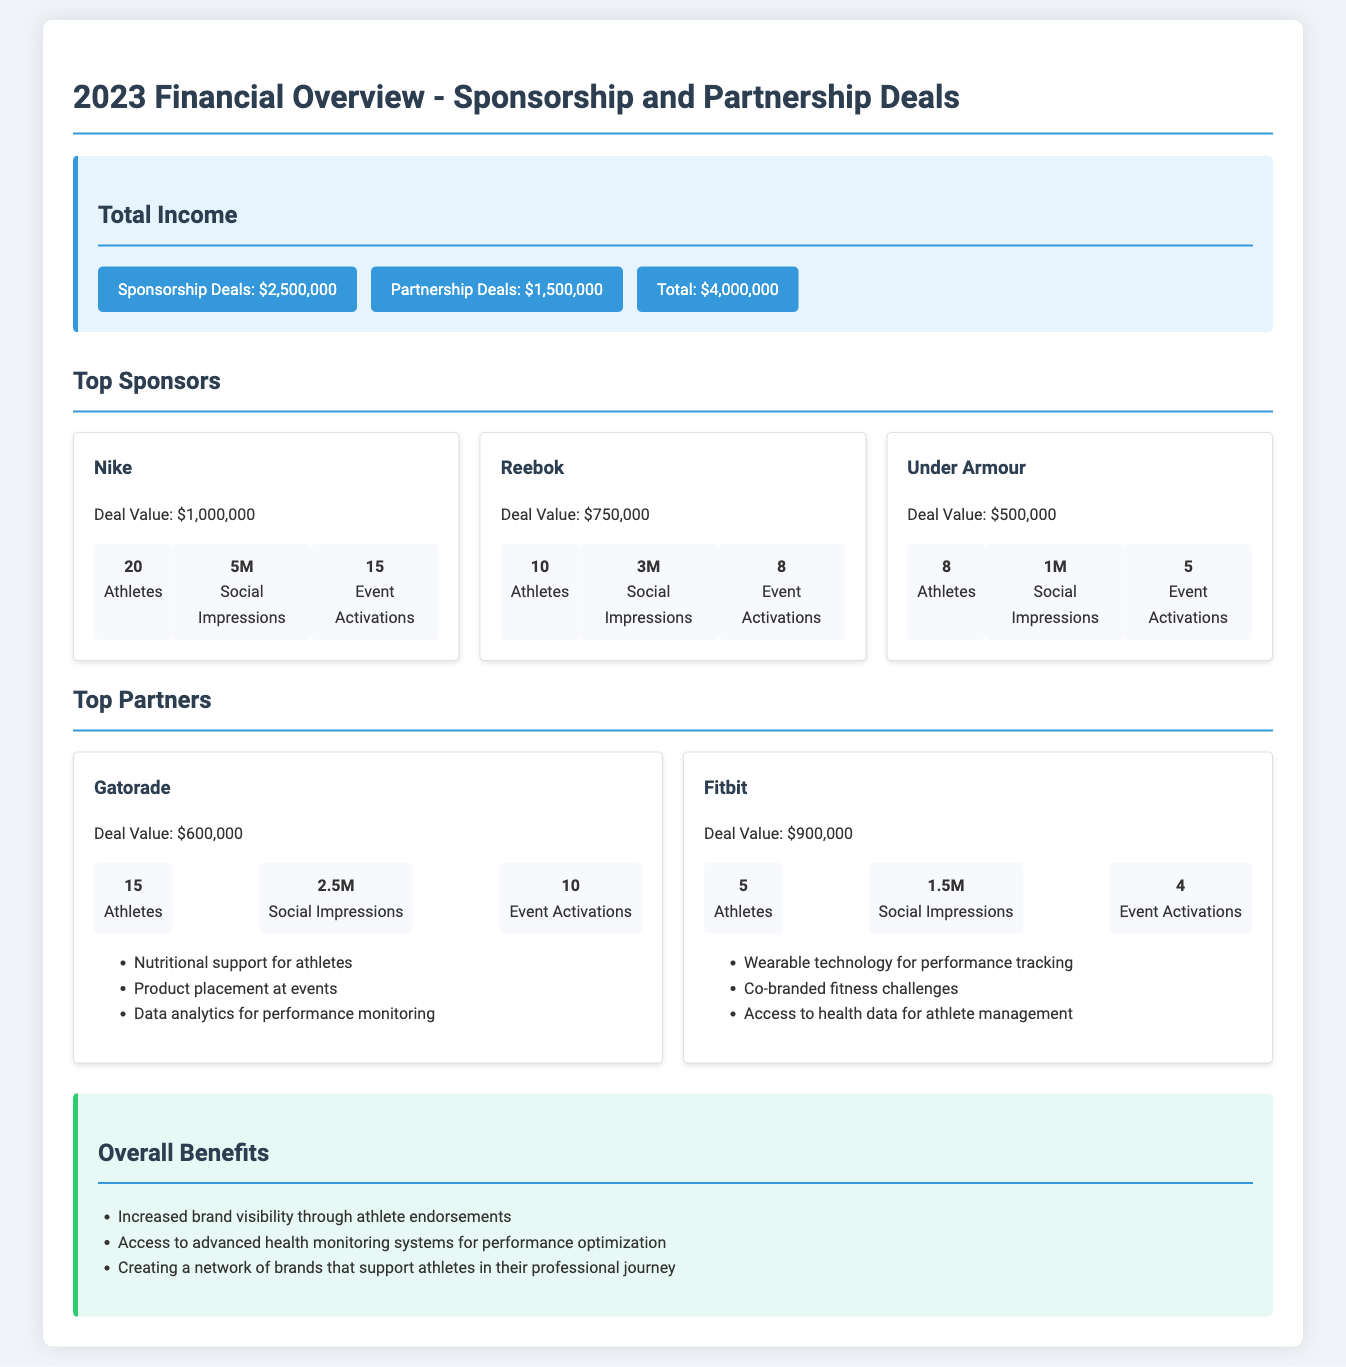What is the total income? The total income is the sum of sponsorship and partnership deals, which is $2,500,000 + $1,500,000 = $4,000,000.
Answer: $4,000,000 Which brand has the highest deal value? The brand with the highest deal value among the sponsors listed is Nike, with a deal value of $1,000,000.
Answer: Nike How many event activations did Reebok have? The document states that Reebok had 8 event activations as part of their sponsorship deal.
Answer: 8 What is the deal value for Fitbit? The deal value for Fitbit, as stated in the document, is $900,000.
Answer: $900,000 How many athletes are associated with Under Armour? Under Armour has 8 athletes associated with it, according to the metrics provided in the document.
Answer: 8 Which sponsor generated the most social impressions? Nike generated the most social impressions, with a total of 5 million impressions.
Answer: 5M What benefits does Gatorade provide to athletes? Gatorade's benefits include nutritional support, product placement, and data analytics for performance monitoring.
Answer: Nutritional support for athletes, product placement at events, data analytics for performance monitoring What is the purpose of the overall benefits section? The overall benefits section outlines the advantages and opportunities that arise from sponsorships and partnerships, emphasizing brand visibility and athlete support.
Answer: Increased brand visibility through athlete endorsements How many top sponsors are listed in the document? There are three top sponsors listed in the document: Nike, Reebok, and Under Armour.
Answer: 3 